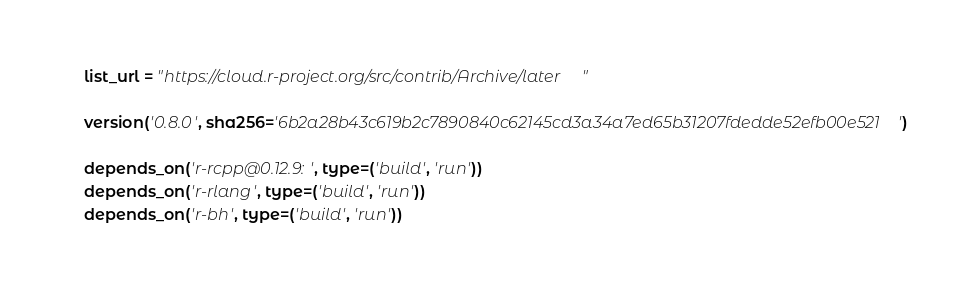<code> <loc_0><loc_0><loc_500><loc_500><_Python_>    list_url = "https://cloud.r-project.org/src/contrib/Archive/later"

    version('0.8.0', sha256='6b2a28b43c619b2c7890840c62145cd3a34a7ed65b31207fdedde52efb00e521')

    depends_on('r-rcpp@0.12.9:', type=('build', 'run'))
    depends_on('r-rlang', type=('build', 'run'))
    depends_on('r-bh', type=('build', 'run'))
</code> 